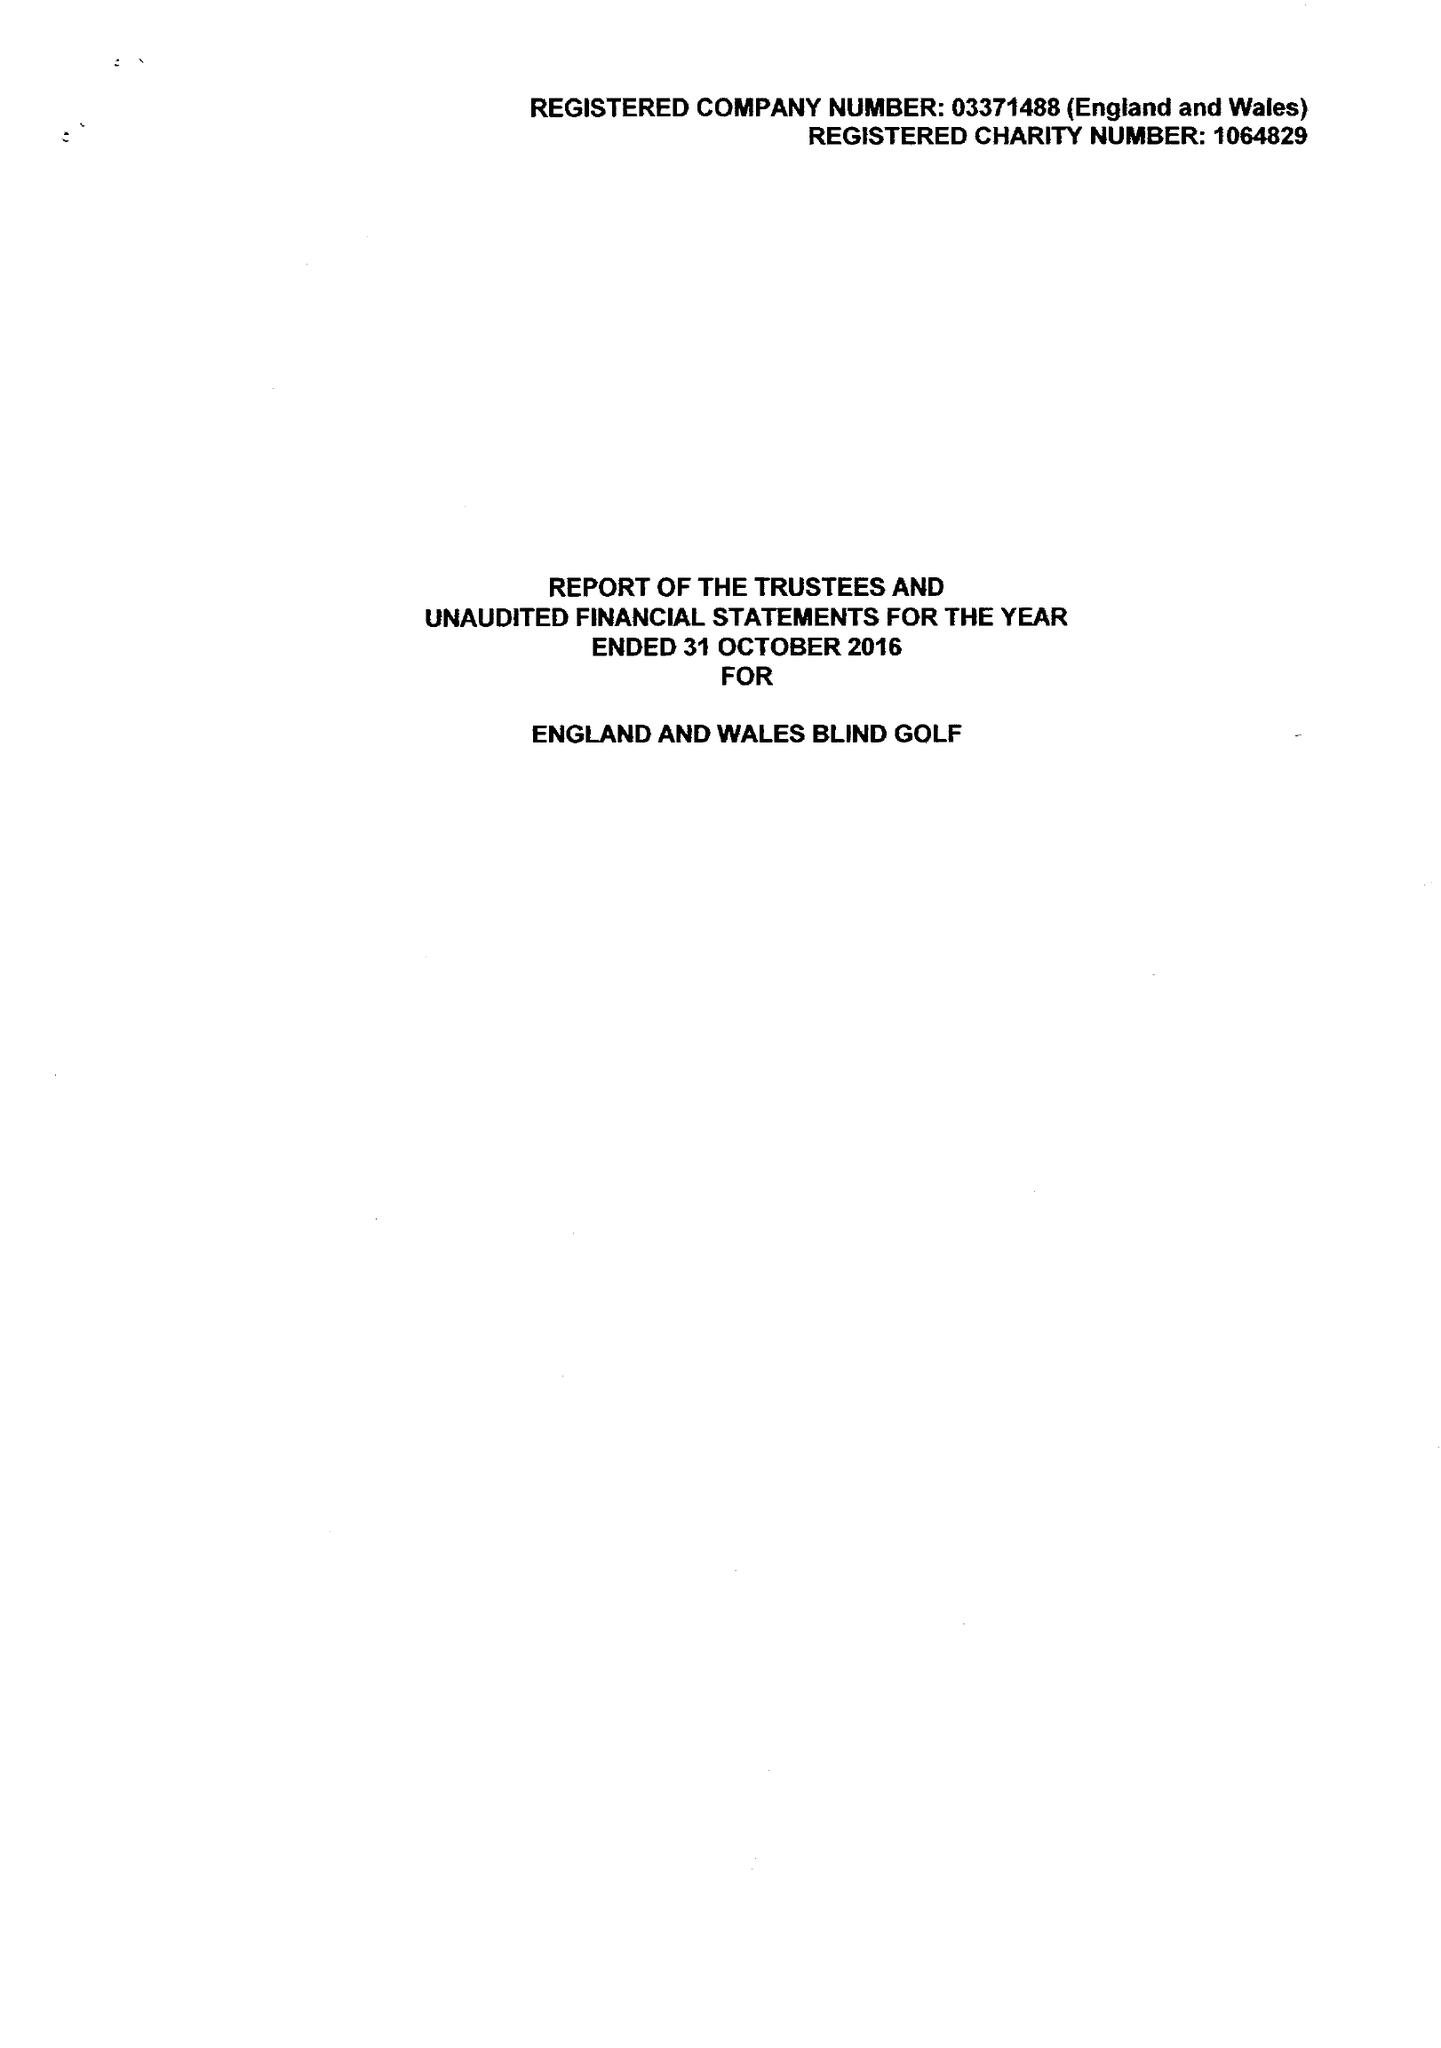What is the value for the charity_name?
Answer the question using a single word or phrase. England and Wales Blind Golf 